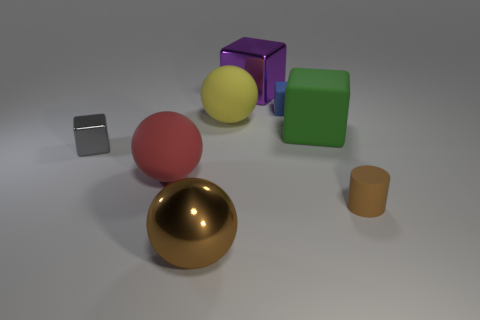There is a brown thing to the left of the matte cylinder; is it the same shape as the big matte object that is to the left of the metallic ball?
Your response must be concise. Yes. What color is the other large cube that is made of the same material as the blue block?
Give a very brief answer. Green. Is the number of tiny brown matte objects greater than the number of big green balls?
Provide a short and direct response. Yes. How many things are either green cubes that are behind the big brown sphere or big shiny spheres?
Your response must be concise. 2. Is there another block that has the same size as the gray cube?
Your response must be concise. Yes. Is the number of yellow matte objects less than the number of big red shiny blocks?
Make the answer very short. No. How many cubes are either yellow objects or small blue rubber things?
Make the answer very short. 1. What number of spheres have the same color as the cylinder?
Offer a very short reply. 1. There is a thing that is both to the left of the brown rubber cylinder and in front of the red object; how big is it?
Keep it short and to the point. Large. Is the number of big rubber spheres that are behind the tiny gray metal block less than the number of gray metallic objects?
Offer a terse response. No. 